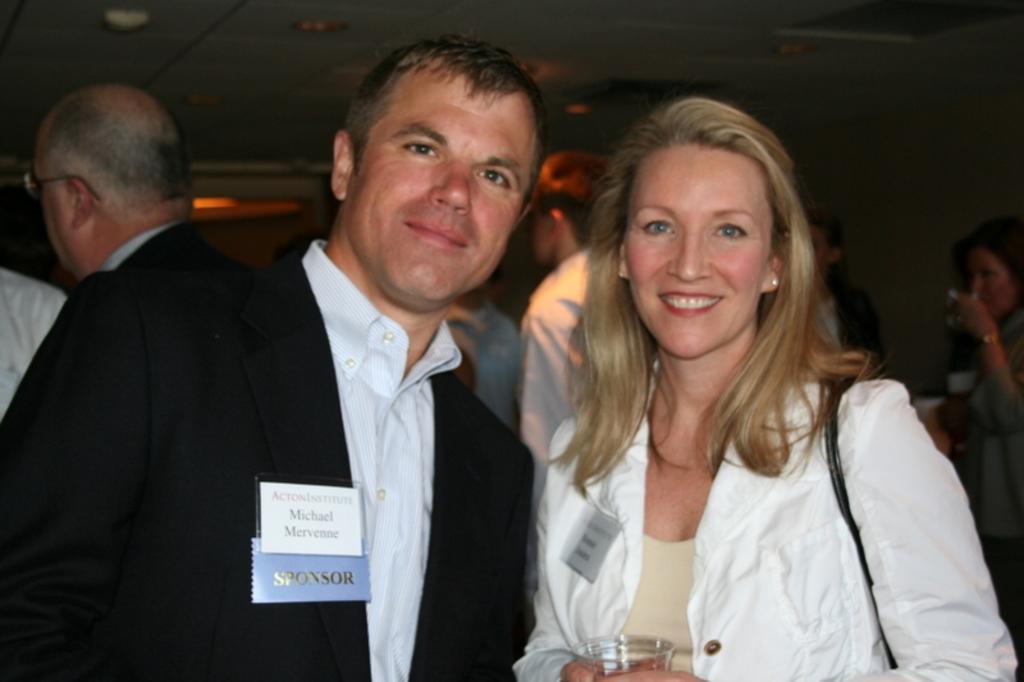Can you describe this image briefly? Here we can see a man and a woman posing to a camera and they are smiling. She is holding a glass with her hand. In the background we can see few persons and this is ceiling. 